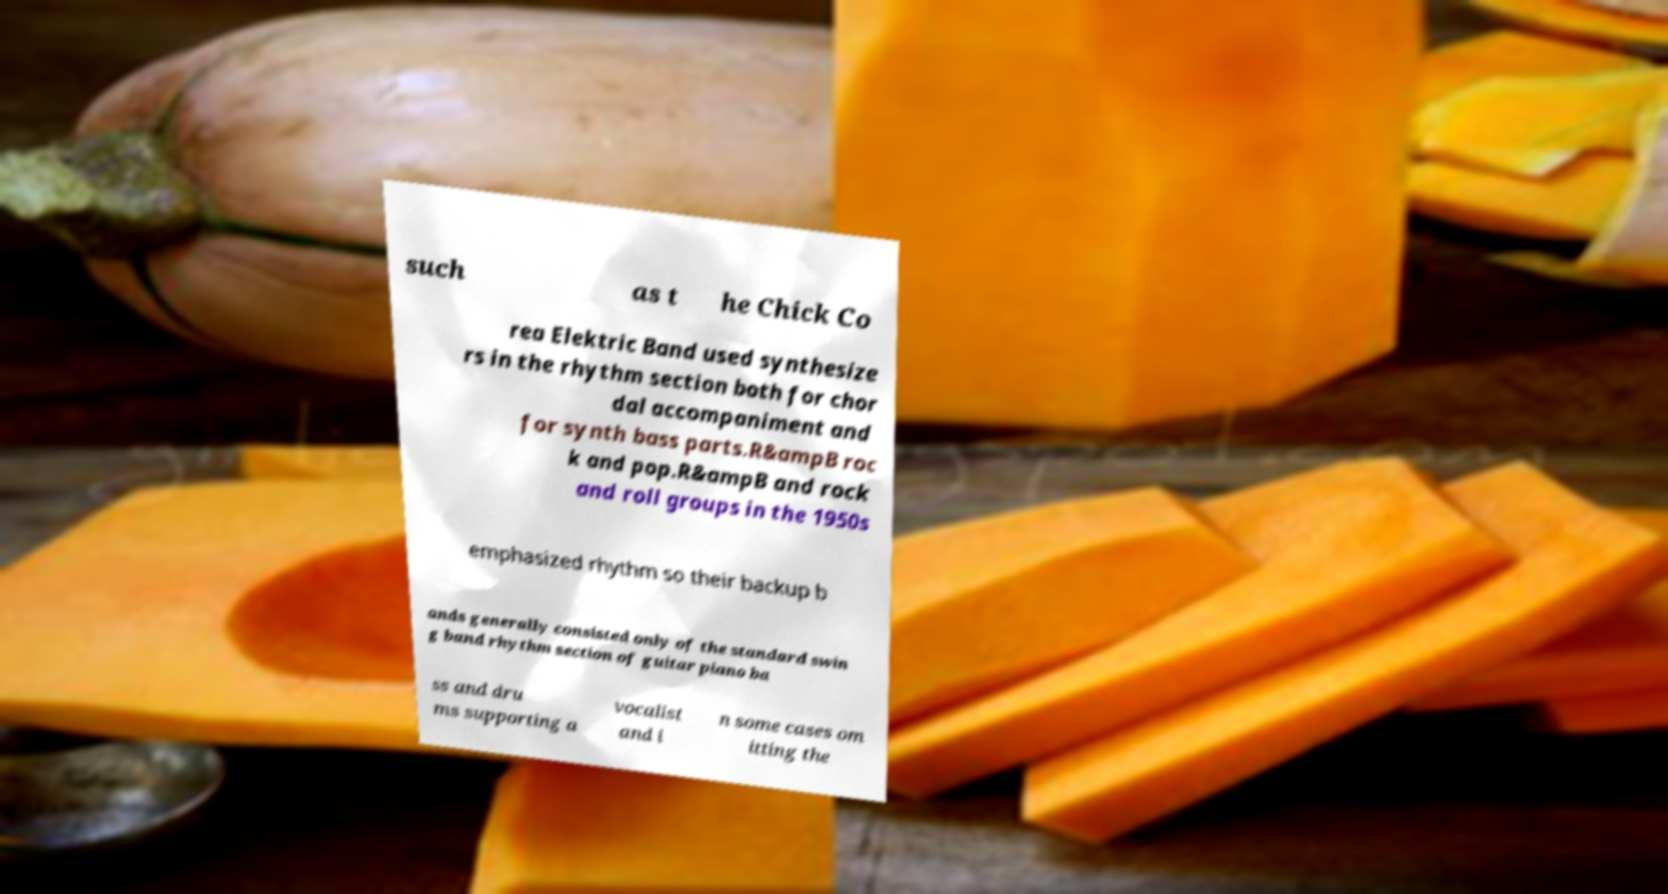I need the written content from this picture converted into text. Can you do that? such as t he Chick Co rea Elektric Band used synthesize rs in the rhythm section both for chor dal accompaniment and for synth bass parts.R&ampB roc k and pop.R&ampB and rock and roll groups in the 1950s emphasized rhythm so their backup b ands generally consisted only of the standard swin g band rhythm section of guitar piano ba ss and dru ms supporting a vocalist and i n some cases om itting the 